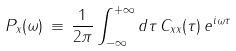Convert formula to latex. <formula><loc_0><loc_0><loc_500><loc_500>P _ { x } ( \omega ) \, \equiv \, \frac { 1 } { 2 \pi } \int _ { - \infty } ^ { + \infty } d \tau \, C _ { x x } ( \tau ) \, e ^ { i \omega \tau }</formula> 